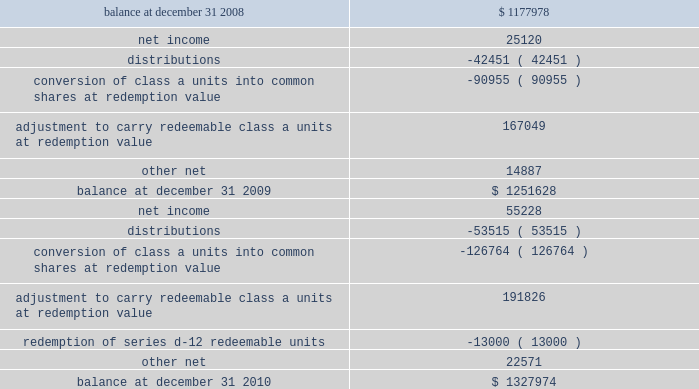Vornado realty trust notes to consolidated financial statements ( continued ) 10 .
Redeemable noncontrolling interests - continued redeemable noncontrolling interests on our consolidated balance sheets are recorded at the greater of their carrying amount or redemption value at the end of each reporting period .
Changes in the value from period to period are charged to 201cadditional capital 201d in our consolidated statements of changes in equity .
Below is a table summarizing the activity of redeemable noncontrolling interests .
( amounts in thousands ) .
As of december 31 , 2010 and 2009 , the aggregate redemption value of redeemable class a units was $ 1066974000 and $ 971628000 , respectively .
Redeemable noncontrolling interests exclude our series g convertible preferred units and series d-13 cumulative redeemable preferred units , as they are accounted for as liabilities in accordance with asc 480 , distinguishing liabilities and equity , because of their possible settlement by issuing a variable number of vornado common shares .
Accordingly the fair value of these units is included as a component of 201cother liabilities 201d on our consolidated balance sheets and aggregated $ 55097000 and $ 60271000 as of december 31 , 2010 and 2009 , respectively. .
What was the percentage change in the redeemable non controlling interests balance at december 31 2009 from 2008? 
Computations: ((1251628 - 1177978) / 1177978)
Answer: 0.06252. 